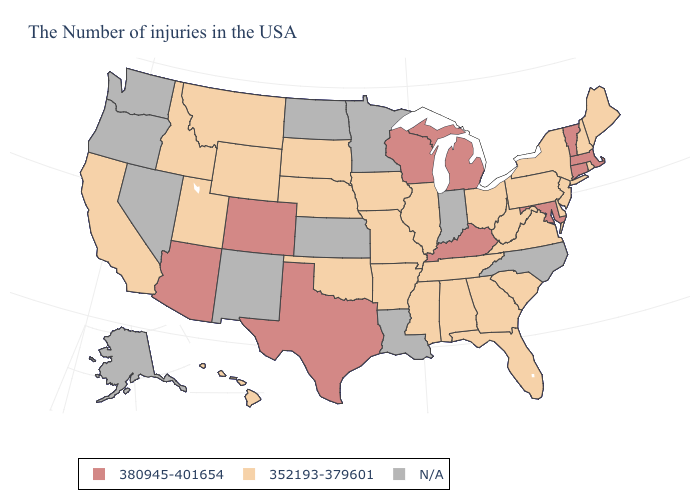Does the first symbol in the legend represent the smallest category?
Quick response, please. No. What is the value of Texas?
Answer briefly. 380945-401654. What is the highest value in the USA?
Short answer required. 380945-401654. Does Alabama have the lowest value in the USA?
Short answer required. Yes. Name the states that have a value in the range 380945-401654?
Be succinct. Massachusetts, Vermont, Connecticut, Maryland, Michigan, Kentucky, Wisconsin, Texas, Colorado, Arizona. What is the lowest value in the USA?
Short answer required. 352193-379601. Does Wisconsin have the lowest value in the USA?
Be succinct. No. Which states hav the highest value in the MidWest?
Quick response, please. Michigan, Wisconsin. Name the states that have a value in the range N/A?
Keep it brief. North Carolina, Indiana, Louisiana, Minnesota, Kansas, North Dakota, New Mexico, Nevada, Washington, Oregon, Alaska. Name the states that have a value in the range N/A?
Quick response, please. North Carolina, Indiana, Louisiana, Minnesota, Kansas, North Dakota, New Mexico, Nevada, Washington, Oregon, Alaska. What is the value of Hawaii?
Keep it brief. 352193-379601. Does Pennsylvania have the lowest value in the Northeast?
Give a very brief answer. Yes. Does Connecticut have the lowest value in the USA?
Concise answer only. No. Among the states that border New Jersey , which have the highest value?
Give a very brief answer. New York, Delaware, Pennsylvania. 